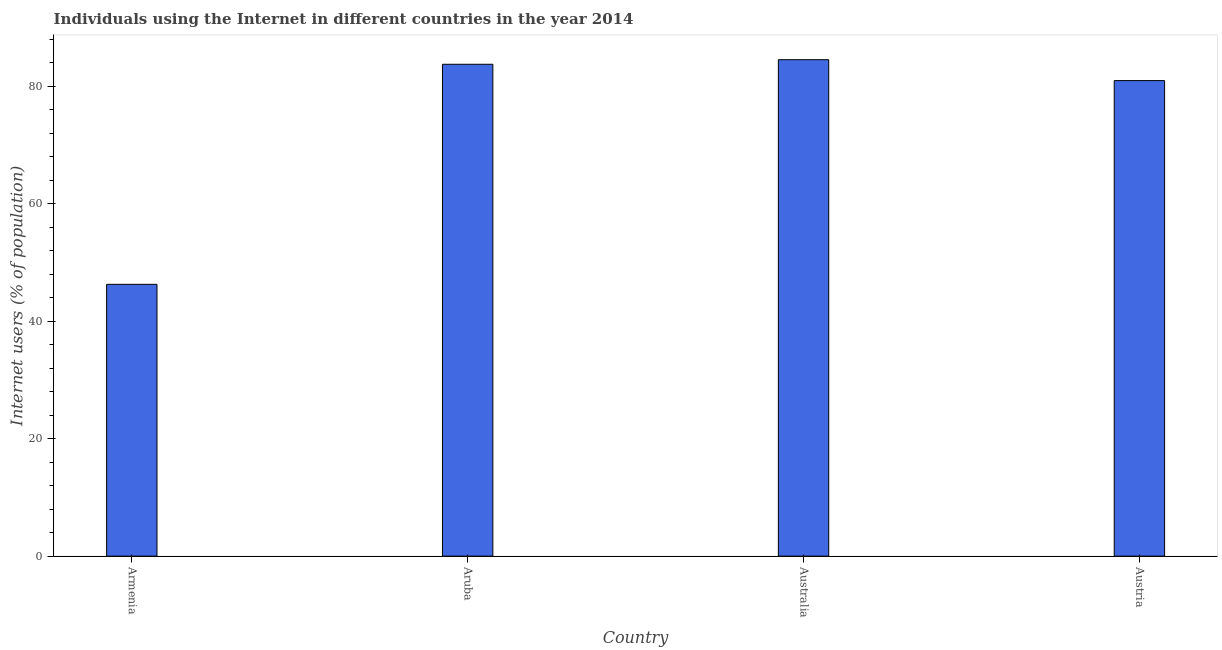What is the title of the graph?
Provide a short and direct response. Individuals using the Internet in different countries in the year 2014. What is the label or title of the Y-axis?
Provide a short and direct response. Internet users (% of population). What is the number of internet users in Aruba?
Provide a succinct answer. 83.78. Across all countries, what is the maximum number of internet users?
Offer a very short reply. 84.56. Across all countries, what is the minimum number of internet users?
Give a very brief answer. 46.3. In which country was the number of internet users minimum?
Your response must be concise. Armenia. What is the sum of the number of internet users?
Your answer should be very brief. 295.64. What is the difference between the number of internet users in Armenia and Aruba?
Your answer should be compact. -37.48. What is the average number of internet users per country?
Your answer should be very brief. 73.91. What is the median number of internet users?
Offer a terse response. 82.39. What is the ratio of the number of internet users in Armenia to that in Australia?
Give a very brief answer. 0.55. Is the number of internet users in Armenia less than that in Australia?
Your answer should be very brief. Yes. Is the difference between the number of internet users in Armenia and Aruba greater than the difference between any two countries?
Make the answer very short. No. What is the difference between the highest and the second highest number of internet users?
Provide a succinct answer. 0.78. What is the difference between the highest and the lowest number of internet users?
Provide a succinct answer. 38.26. How many bars are there?
Provide a succinct answer. 4. Are all the bars in the graph horizontal?
Provide a short and direct response. No. What is the difference between two consecutive major ticks on the Y-axis?
Offer a very short reply. 20. What is the Internet users (% of population) of Armenia?
Give a very brief answer. 46.3. What is the Internet users (% of population) in Aruba?
Your answer should be compact. 83.78. What is the Internet users (% of population) of Australia?
Provide a short and direct response. 84.56. What is the Internet users (% of population) of Austria?
Keep it short and to the point. 81. What is the difference between the Internet users (% of population) in Armenia and Aruba?
Ensure brevity in your answer.  -37.48. What is the difference between the Internet users (% of population) in Armenia and Australia?
Give a very brief answer. -38.26. What is the difference between the Internet users (% of population) in Armenia and Austria?
Provide a succinct answer. -34.7. What is the difference between the Internet users (% of population) in Aruba and Australia?
Your answer should be compact. -0.78. What is the difference between the Internet users (% of population) in Aruba and Austria?
Ensure brevity in your answer.  2.78. What is the difference between the Internet users (% of population) in Australia and Austria?
Provide a succinct answer. 3.56. What is the ratio of the Internet users (% of population) in Armenia to that in Aruba?
Your response must be concise. 0.55. What is the ratio of the Internet users (% of population) in Armenia to that in Australia?
Your answer should be compact. 0.55. What is the ratio of the Internet users (% of population) in Armenia to that in Austria?
Provide a short and direct response. 0.57. What is the ratio of the Internet users (% of population) in Aruba to that in Austria?
Your answer should be compact. 1.03. What is the ratio of the Internet users (% of population) in Australia to that in Austria?
Ensure brevity in your answer.  1.04. 